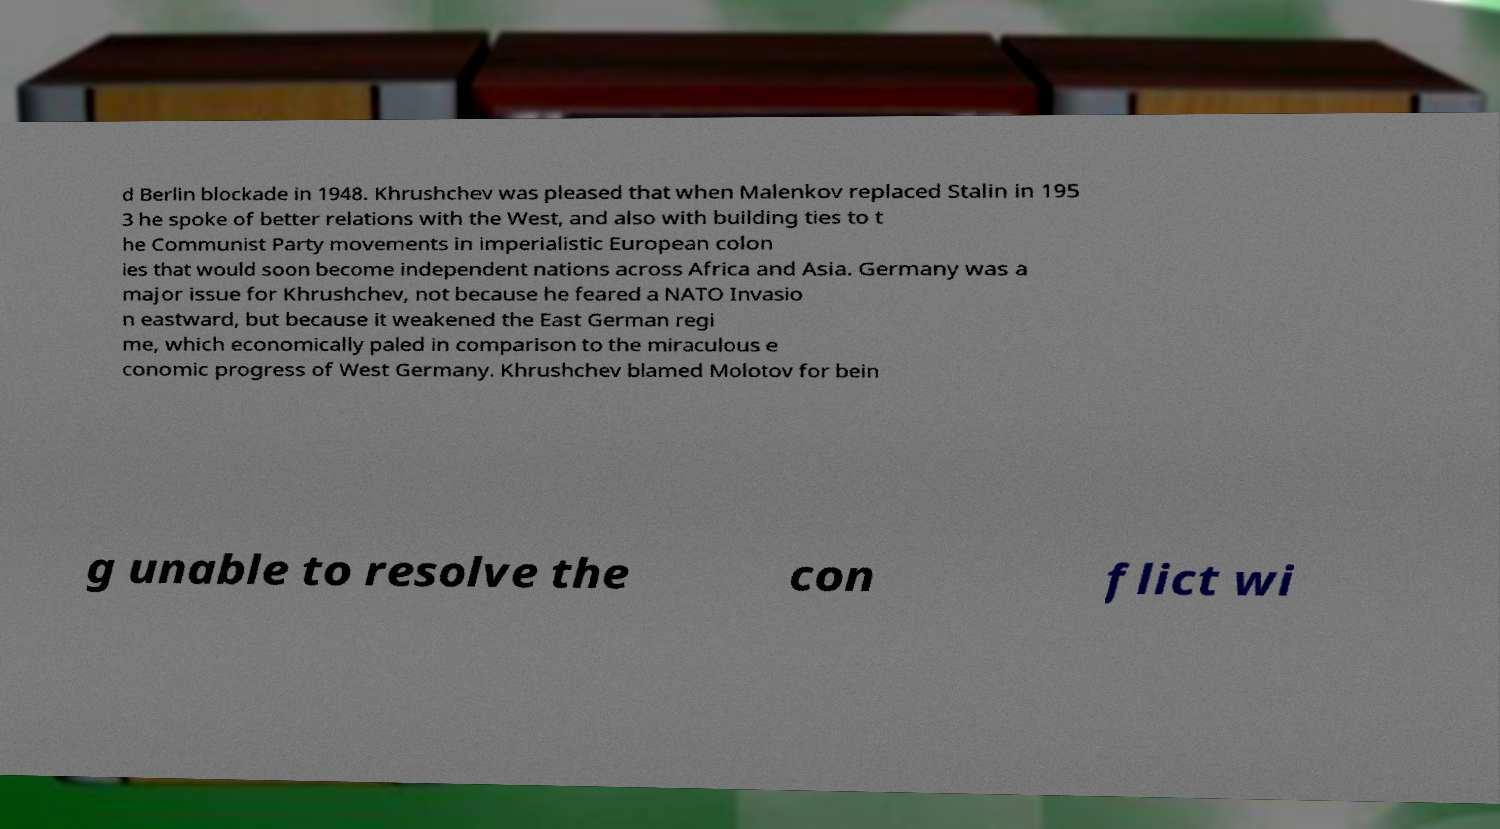Could you extract and type out the text from this image? d Berlin blockade in 1948. Khrushchev was pleased that when Malenkov replaced Stalin in 195 3 he spoke of better relations with the West, and also with building ties to t he Communist Party movements in imperialistic European colon ies that would soon become independent nations across Africa and Asia. Germany was a major issue for Khrushchev, not because he feared a NATO Invasio n eastward, but because it weakened the East German regi me, which economically paled in comparison to the miraculous e conomic progress of West Germany. Khrushchev blamed Molotov for bein g unable to resolve the con flict wi 